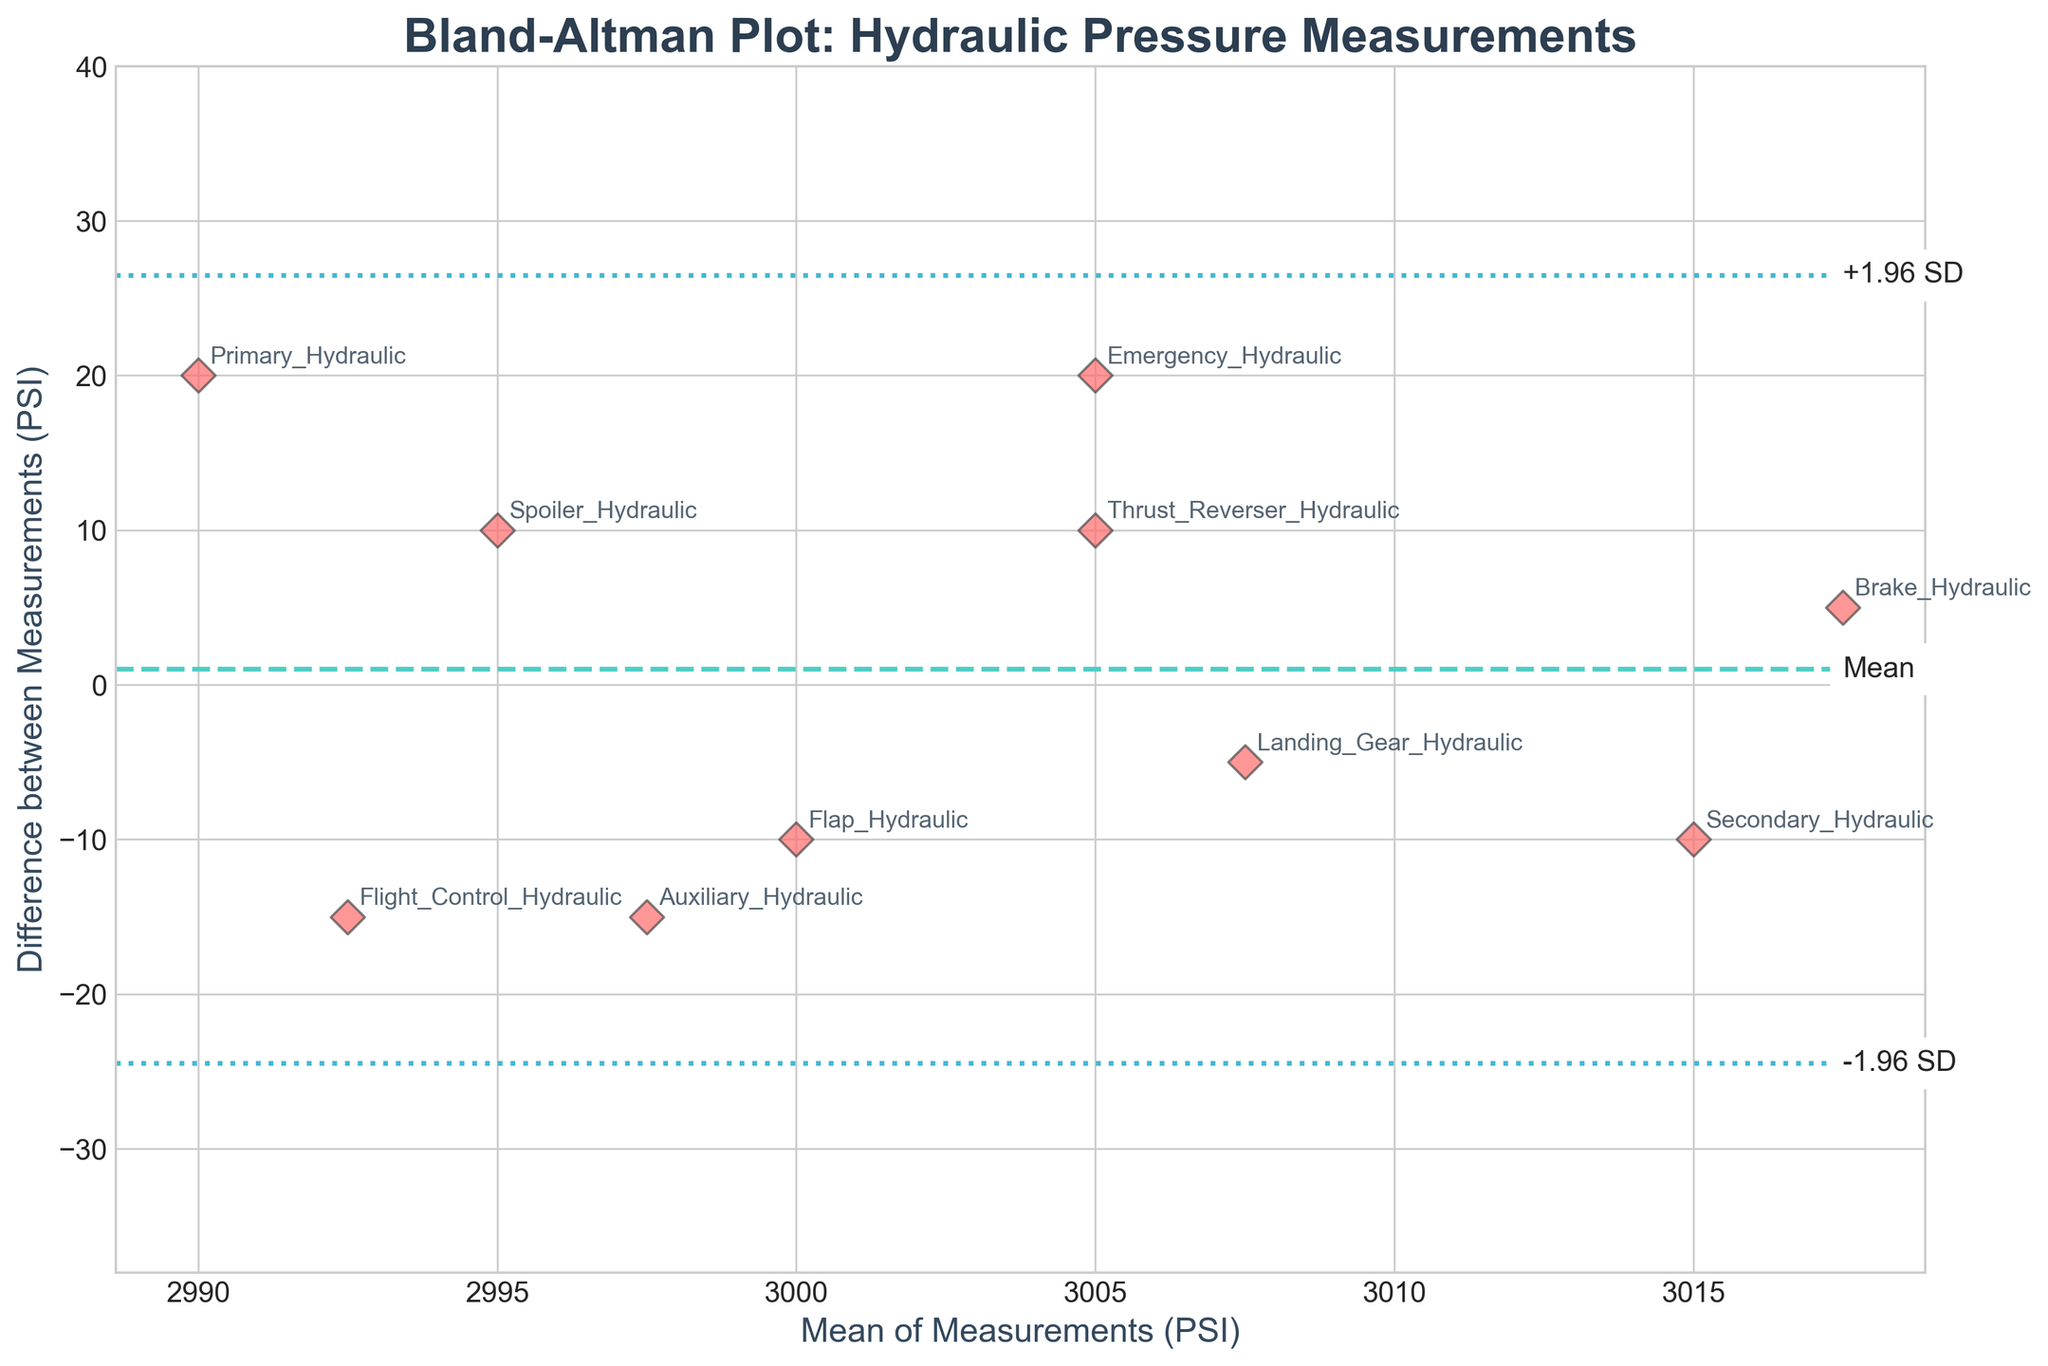What is the title of the plot? The title of the plot is usually given at the top of the figure and is easy to read. In this case, the title is clearly visible.
Answer: Bland-Altman Plot: Hydraulic Pressure Measurements How many data points are there? Count the number of individual markers (diamonds) on the plot. Each marker represents a data point.
Answer: 10 What does the y-axis represent? The y-axis label is provided in the figure and it explains what the vertical measurements denote.
Answer: Difference between Measurements (PSI) What is the mean difference between the measurements? The horizontal line in the center of the plot represents the mean difference between the measurements. It is often annotated or can be located at its intersection with the y-axis.
Answer: Approximately 0 PSI What is the significance of the dashed lines above and below the mean line? These dashed lines, positioned above and below the mean line, typically represent 1.96 standard deviations from the mean, indicating the limits of agreement. This can be confirmed by their annotation.
Answer: They represent ±1.96 standard deviations from the mean Which hydraulic system has the highest mean pressure measurement? Identify the data point with the highest x-coordinate (mean of Measurement1 and Measurement2). Then check the annotation for that point.
Answer: Landing_Gear_Hydraulic What is the difference in measurements for the system with the lowest mean value? First, find the data point with the lowest x-coordinate. Then, refer to its y-coordinate to get the difference.
Answer: Approximately -15 PSI Is there any hydraulic system that shows a zero difference between measurements? Look for any data points that lie exactly on the mean line (y=0). Then, check the annotations near these points.
Answer: Yes, the Auxiliary_Hydraulic system Which hydraulic system shows the largest discrepancy in measurements? Find the data point with the largest absolute value on the y-axis and refer to its annotation.
Answer: Emergency_Hydraulic system Are there more systems with positive differences or negative differences? Count the number of data points above and below the mean line (y=0) to determine the prevalence of positive and negative differences.
Answer: Equal (5 positive, 5 negative) 